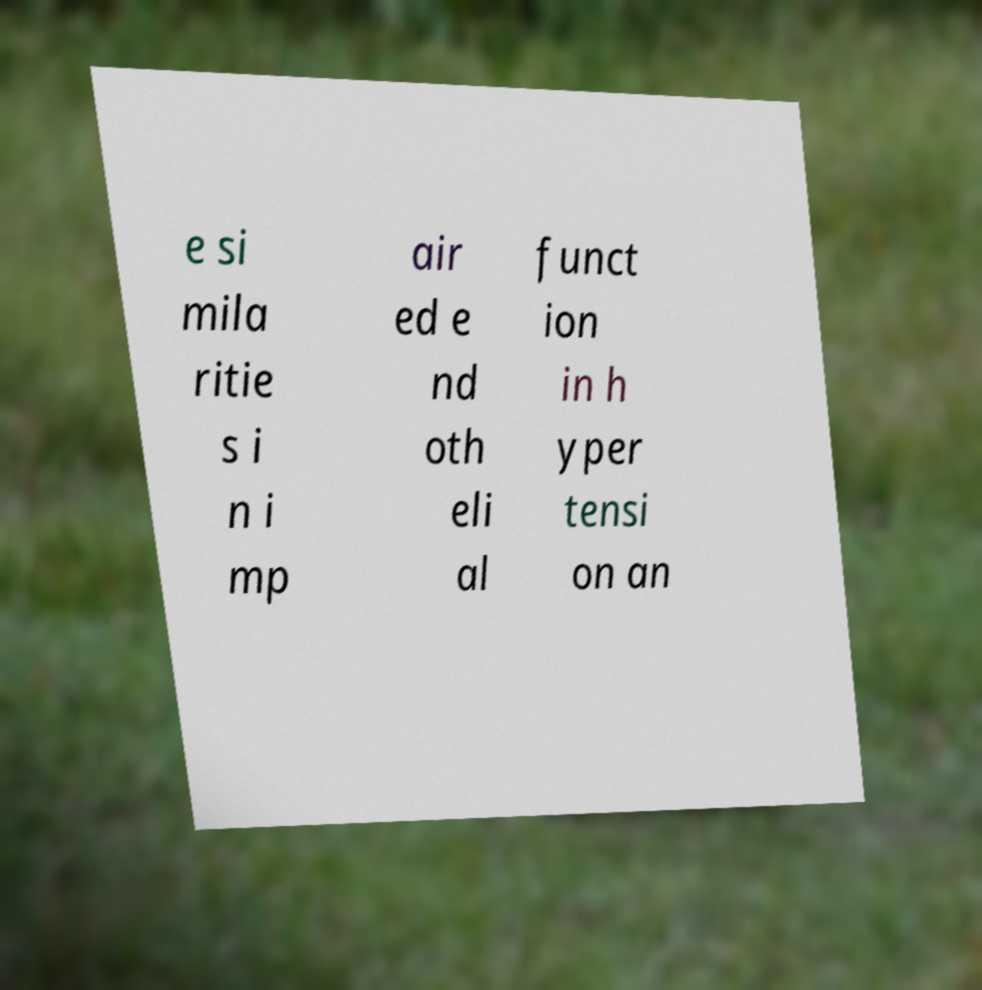There's text embedded in this image that I need extracted. Can you transcribe it verbatim? e si mila ritie s i n i mp air ed e nd oth eli al funct ion in h yper tensi on an 